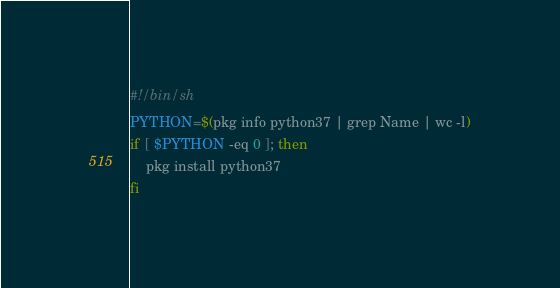<code> <loc_0><loc_0><loc_500><loc_500><_Bash_>#!/bin/sh
PYTHON=$(pkg info python37 | grep Name | wc -l)
if [ $PYTHON -eq 0 ]; then
	pkg install python37
fi
</code> 